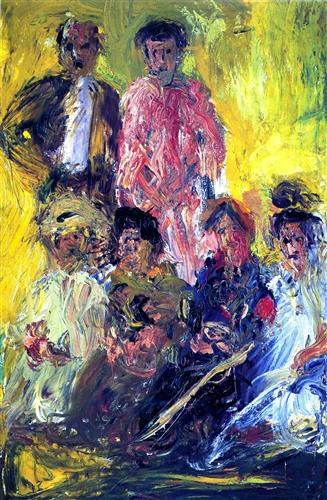Can you describe the technique the artist used? The artist employed thick, impasto brushstrokes that stand out in relief, adding texture to the surface. This technique emphasizes the physicality of the paint, which becomes almost sculptural in some areas. Quick, gestural strokes capture the essence of the figures without focusing on precise detail, allowing color and form to carry the narrative and emotional weight. 